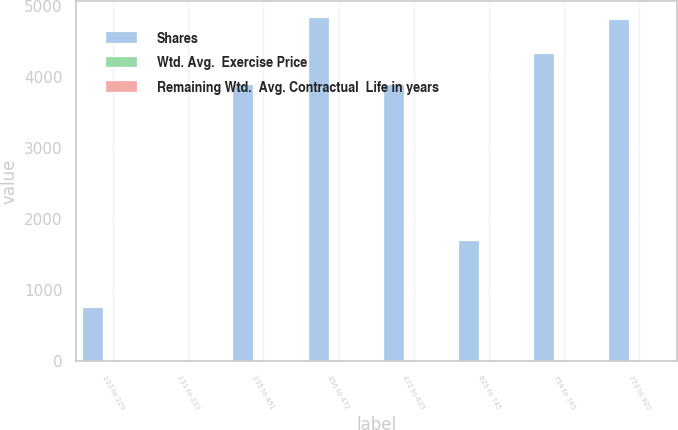<chart> <loc_0><loc_0><loc_500><loc_500><stacked_bar_chart><ecel><fcel>133 to 229<fcel>231 to 233<fcel>235 to 451<fcel>456 to 472<fcel>472 to 625<fcel>625 to 745<fcel>754 to 765<fcel>773 to 920<nl><fcel>Shares<fcel>758<fcel>7.37<fcel>3891<fcel>4834<fcel>3887<fcel>1696<fcel>4324<fcel>4814<nl><fcel>Wtd. Avg.  Exercise Price<fcel>5.11<fcel>3.98<fcel>7.31<fcel>7.37<fcel>7.53<fcel>7.96<fcel>7.32<fcel>7.12<nl><fcel>Remaining Wtd.  Avg. Contractual  Life in years<fcel>1.49<fcel>2.33<fcel>4.14<fcel>4.69<fcel>5.47<fcel>7.06<fcel>7.65<fcel>8.98<nl></chart> 